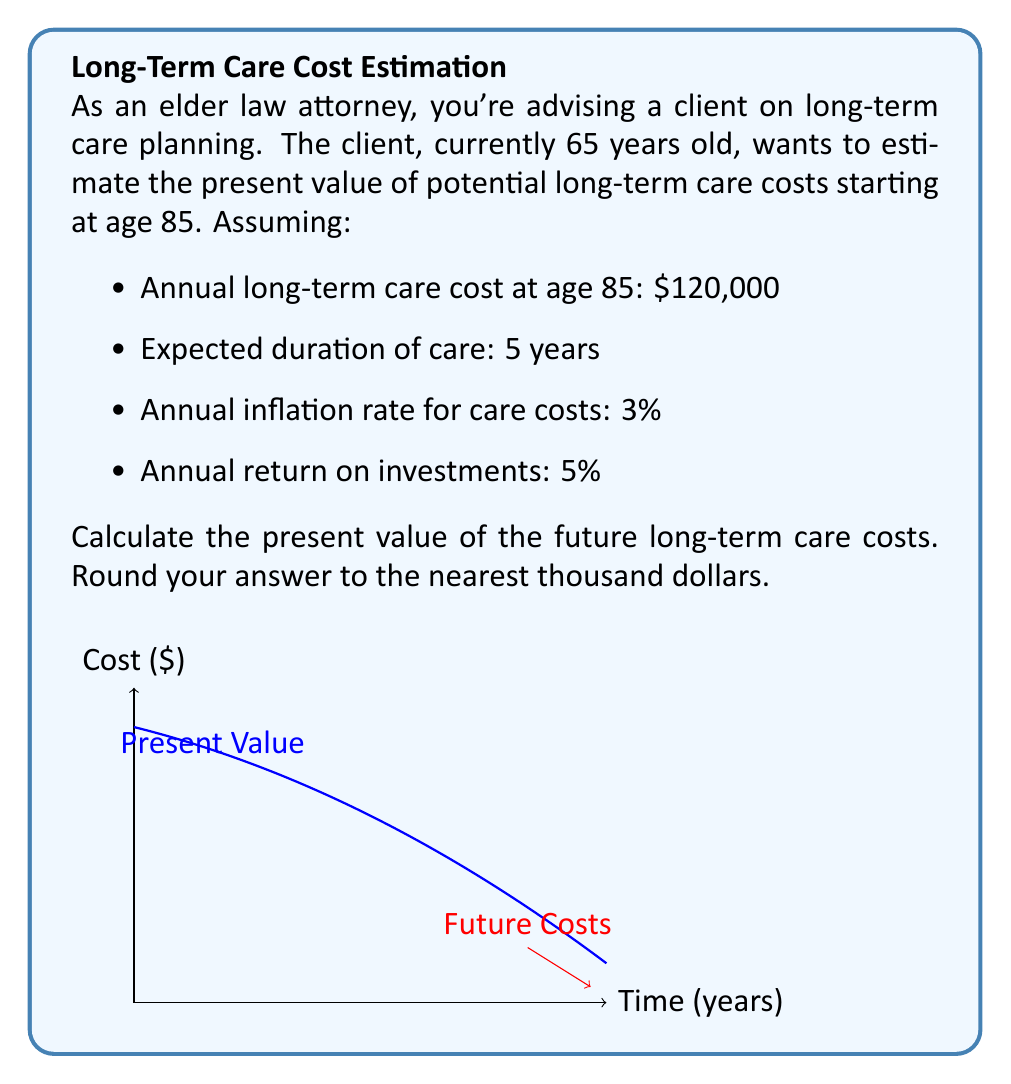Teach me how to tackle this problem. Let's approach this problem step-by-step:

1) First, we need to calculate the future value of the annual long-term care cost after 20 years of inflation:
   $FV = 120000 * (1 + 0.03)^{20} = 216,722.54$

2) Now, we have a series of 5 annual payments of $216,722.54 starting 20 years from now. We need to find the present value of this series.

3) The formula for the present value of a series of future payments is:
   $$PV = \frac{PMT}{r} * (1 - \frac{1}{(1+r)^n}) * \frac{1}{(1+r)^{t}}$$
   Where:
   PMT = Annual payment
   r = Discount rate
   n = Number of payments
   t = Years until first payment

4) Plugging in our values:
   PMT = $216,722.54
   r = 0.05 (5% return on investments)
   n = 5 (5 years of care)
   t = 20 (care starts in 20 years)

5) Calculating:
   $$PV = \frac{216722.54}{0.05} * (1 - \frac{1}{(1+0.05)^5}) * \frac{1}{(1+0.05)^{20}}$$
   
   $$PV = 4334450.8 * (1 - 0.7835) * 0.3769$$
   
   $$PV = 4334450.8 * 0.2165 * 0.3769$$
   
   $$PV = 353,968.95$$

6) Rounding to the nearest thousand:
   PV ≈ $354,000
Answer: $354,000 